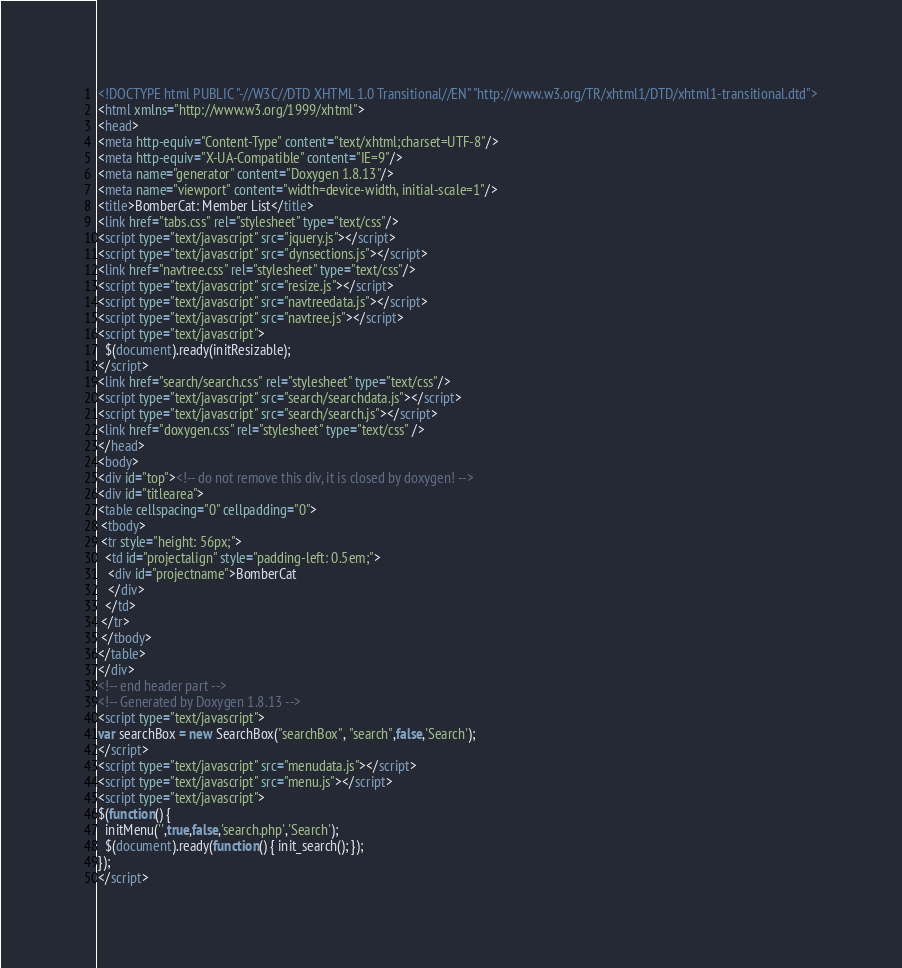Convert code to text. <code><loc_0><loc_0><loc_500><loc_500><_HTML_><!DOCTYPE html PUBLIC "-//W3C//DTD XHTML 1.0 Transitional//EN" "http://www.w3.org/TR/xhtml1/DTD/xhtml1-transitional.dtd">
<html xmlns="http://www.w3.org/1999/xhtml">
<head>
<meta http-equiv="Content-Type" content="text/xhtml;charset=UTF-8"/>
<meta http-equiv="X-UA-Compatible" content="IE=9"/>
<meta name="generator" content="Doxygen 1.8.13"/>
<meta name="viewport" content="width=device-width, initial-scale=1"/>
<title>BomberCat: Member List</title>
<link href="tabs.css" rel="stylesheet" type="text/css"/>
<script type="text/javascript" src="jquery.js"></script>
<script type="text/javascript" src="dynsections.js"></script>
<link href="navtree.css" rel="stylesheet" type="text/css"/>
<script type="text/javascript" src="resize.js"></script>
<script type="text/javascript" src="navtreedata.js"></script>
<script type="text/javascript" src="navtree.js"></script>
<script type="text/javascript">
  $(document).ready(initResizable);
</script>
<link href="search/search.css" rel="stylesheet" type="text/css"/>
<script type="text/javascript" src="search/searchdata.js"></script>
<script type="text/javascript" src="search/search.js"></script>
<link href="doxygen.css" rel="stylesheet" type="text/css" />
</head>
<body>
<div id="top"><!-- do not remove this div, it is closed by doxygen! -->
<div id="titlearea">
<table cellspacing="0" cellpadding="0">
 <tbody>
 <tr style="height: 56px;">
  <td id="projectalign" style="padding-left: 0.5em;">
   <div id="projectname">BomberCat
   </div>
  </td>
 </tr>
 </tbody>
</table>
</div>
<!-- end header part -->
<!-- Generated by Doxygen 1.8.13 -->
<script type="text/javascript">
var searchBox = new SearchBox("searchBox", "search",false,'Search');
</script>
<script type="text/javascript" src="menudata.js"></script>
<script type="text/javascript" src="menu.js"></script>
<script type="text/javascript">
$(function() {
  initMenu('',true,false,'search.php','Search');
  $(document).ready(function() { init_search(); });
});
</script></code> 